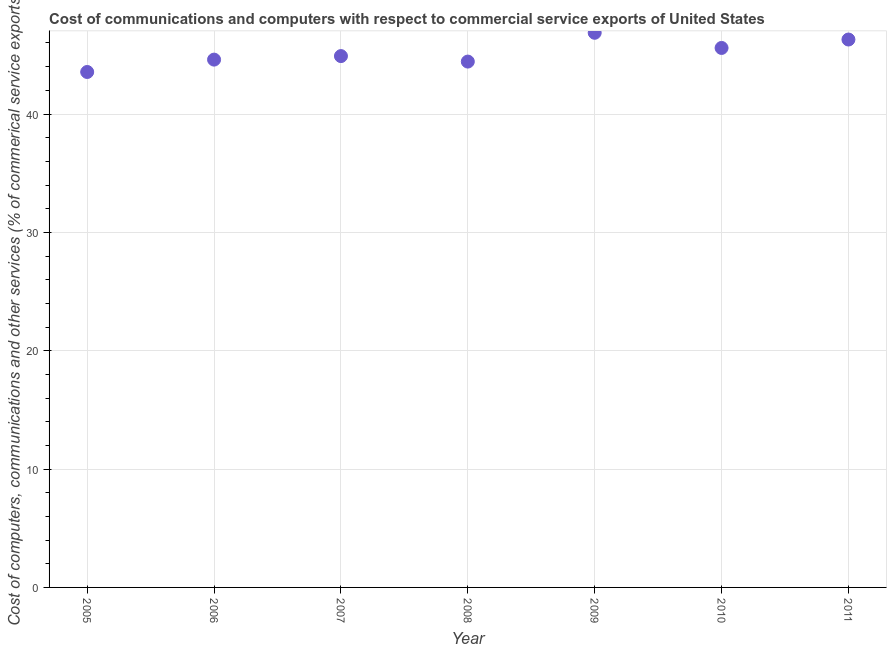What is the cost of communications in 2009?
Give a very brief answer. 46.86. Across all years, what is the maximum cost of communications?
Offer a terse response. 46.86. Across all years, what is the minimum  computer and other services?
Offer a terse response. 43.55. In which year was the  computer and other services minimum?
Give a very brief answer. 2005. What is the sum of the  computer and other services?
Your answer should be very brief. 316.21. What is the difference between the  computer and other services in 2005 and 2007?
Your answer should be very brief. -1.34. What is the average  computer and other services per year?
Offer a very short reply. 45.17. What is the median cost of communications?
Provide a succinct answer. 44.89. Do a majority of the years between 2009 and 2007 (inclusive) have  computer and other services greater than 44 %?
Give a very brief answer. No. What is the ratio of the  computer and other services in 2006 to that in 2007?
Give a very brief answer. 0.99. Is the difference between the cost of communications in 2008 and 2010 greater than the difference between any two years?
Your response must be concise. No. What is the difference between the highest and the second highest  computer and other services?
Provide a short and direct response. 0.57. Is the sum of the cost of communications in 2006 and 2011 greater than the maximum cost of communications across all years?
Ensure brevity in your answer.  Yes. What is the difference between the highest and the lowest  computer and other services?
Your answer should be compact. 3.31. Does the  computer and other services monotonically increase over the years?
Give a very brief answer. No. How many years are there in the graph?
Keep it short and to the point. 7. What is the difference between two consecutive major ticks on the Y-axis?
Offer a very short reply. 10. Does the graph contain grids?
Make the answer very short. Yes. What is the title of the graph?
Provide a succinct answer. Cost of communications and computers with respect to commercial service exports of United States. What is the label or title of the Y-axis?
Offer a terse response. Cost of computers, communications and other services (% of commerical service exports). What is the Cost of computers, communications and other services (% of commerical service exports) in 2005?
Offer a very short reply. 43.55. What is the Cost of computers, communications and other services (% of commerical service exports) in 2006?
Offer a terse response. 44.6. What is the Cost of computers, communications and other services (% of commerical service exports) in 2007?
Offer a very short reply. 44.89. What is the Cost of computers, communications and other services (% of commerical service exports) in 2008?
Give a very brief answer. 44.43. What is the Cost of computers, communications and other services (% of commerical service exports) in 2009?
Make the answer very short. 46.86. What is the Cost of computers, communications and other services (% of commerical service exports) in 2010?
Give a very brief answer. 45.58. What is the Cost of computers, communications and other services (% of commerical service exports) in 2011?
Provide a succinct answer. 46.29. What is the difference between the Cost of computers, communications and other services (% of commerical service exports) in 2005 and 2006?
Offer a very short reply. -1.05. What is the difference between the Cost of computers, communications and other services (% of commerical service exports) in 2005 and 2007?
Give a very brief answer. -1.34. What is the difference between the Cost of computers, communications and other services (% of commerical service exports) in 2005 and 2008?
Provide a succinct answer. -0.88. What is the difference between the Cost of computers, communications and other services (% of commerical service exports) in 2005 and 2009?
Provide a succinct answer. -3.31. What is the difference between the Cost of computers, communications and other services (% of commerical service exports) in 2005 and 2010?
Your response must be concise. -2.03. What is the difference between the Cost of computers, communications and other services (% of commerical service exports) in 2005 and 2011?
Give a very brief answer. -2.74. What is the difference between the Cost of computers, communications and other services (% of commerical service exports) in 2006 and 2007?
Your answer should be compact. -0.3. What is the difference between the Cost of computers, communications and other services (% of commerical service exports) in 2006 and 2008?
Provide a short and direct response. 0.17. What is the difference between the Cost of computers, communications and other services (% of commerical service exports) in 2006 and 2009?
Offer a terse response. -2.27. What is the difference between the Cost of computers, communications and other services (% of commerical service exports) in 2006 and 2010?
Keep it short and to the point. -0.99. What is the difference between the Cost of computers, communications and other services (% of commerical service exports) in 2006 and 2011?
Offer a terse response. -1.7. What is the difference between the Cost of computers, communications and other services (% of commerical service exports) in 2007 and 2008?
Offer a terse response. 0.46. What is the difference between the Cost of computers, communications and other services (% of commerical service exports) in 2007 and 2009?
Provide a succinct answer. -1.97. What is the difference between the Cost of computers, communications and other services (% of commerical service exports) in 2007 and 2010?
Ensure brevity in your answer.  -0.69. What is the difference between the Cost of computers, communications and other services (% of commerical service exports) in 2007 and 2011?
Make the answer very short. -1.4. What is the difference between the Cost of computers, communications and other services (% of commerical service exports) in 2008 and 2009?
Ensure brevity in your answer.  -2.43. What is the difference between the Cost of computers, communications and other services (% of commerical service exports) in 2008 and 2010?
Ensure brevity in your answer.  -1.15. What is the difference between the Cost of computers, communications and other services (% of commerical service exports) in 2008 and 2011?
Keep it short and to the point. -1.86. What is the difference between the Cost of computers, communications and other services (% of commerical service exports) in 2009 and 2010?
Offer a terse response. 1.28. What is the difference between the Cost of computers, communications and other services (% of commerical service exports) in 2009 and 2011?
Offer a terse response. 0.57. What is the difference between the Cost of computers, communications and other services (% of commerical service exports) in 2010 and 2011?
Your answer should be very brief. -0.71. What is the ratio of the Cost of computers, communications and other services (% of commerical service exports) in 2005 to that in 2006?
Your answer should be very brief. 0.98. What is the ratio of the Cost of computers, communications and other services (% of commerical service exports) in 2005 to that in 2009?
Your answer should be compact. 0.93. What is the ratio of the Cost of computers, communications and other services (% of commerical service exports) in 2005 to that in 2010?
Make the answer very short. 0.95. What is the ratio of the Cost of computers, communications and other services (% of commerical service exports) in 2005 to that in 2011?
Your response must be concise. 0.94. What is the ratio of the Cost of computers, communications and other services (% of commerical service exports) in 2006 to that in 2008?
Make the answer very short. 1. What is the ratio of the Cost of computers, communications and other services (% of commerical service exports) in 2006 to that in 2010?
Your answer should be very brief. 0.98. What is the ratio of the Cost of computers, communications and other services (% of commerical service exports) in 2007 to that in 2009?
Provide a short and direct response. 0.96. What is the ratio of the Cost of computers, communications and other services (% of commerical service exports) in 2008 to that in 2009?
Your answer should be very brief. 0.95. What is the ratio of the Cost of computers, communications and other services (% of commerical service exports) in 2009 to that in 2010?
Offer a very short reply. 1.03. What is the ratio of the Cost of computers, communications and other services (% of commerical service exports) in 2009 to that in 2011?
Make the answer very short. 1.01. What is the ratio of the Cost of computers, communications and other services (% of commerical service exports) in 2010 to that in 2011?
Give a very brief answer. 0.98. 